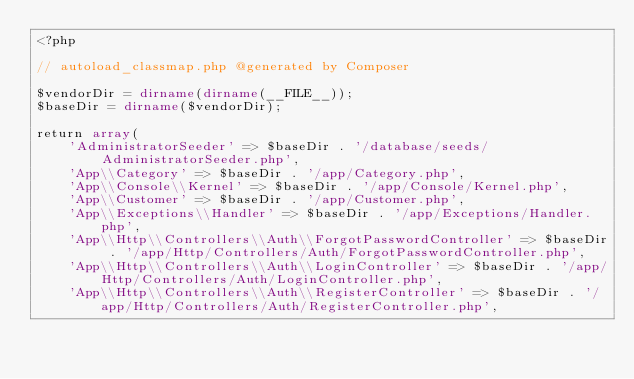Convert code to text. <code><loc_0><loc_0><loc_500><loc_500><_PHP_><?php

// autoload_classmap.php @generated by Composer

$vendorDir = dirname(dirname(__FILE__));
$baseDir = dirname($vendorDir);

return array(
    'AdministratorSeeder' => $baseDir . '/database/seeds/AdministratorSeeder.php',
    'App\\Category' => $baseDir . '/app/Category.php',
    'App\\Console\\Kernel' => $baseDir . '/app/Console/Kernel.php',
    'App\\Customer' => $baseDir . '/app/Customer.php',
    'App\\Exceptions\\Handler' => $baseDir . '/app/Exceptions/Handler.php',
    'App\\Http\\Controllers\\Auth\\ForgotPasswordController' => $baseDir . '/app/Http/Controllers/Auth/ForgotPasswordController.php',
    'App\\Http\\Controllers\\Auth\\LoginController' => $baseDir . '/app/Http/Controllers/Auth/LoginController.php',
    'App\\Http\\Controllers\\Auth\\RegisterController' => $baseDir . '/app/Http/Controllers/Auth/RegisterController.php',</code> 